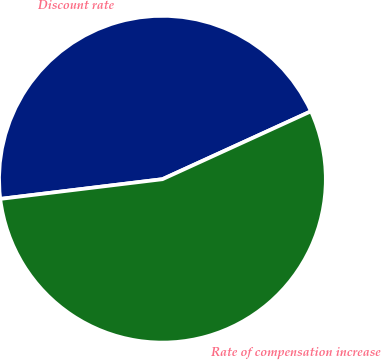<chart> <loc_0><loc_0><loc_500><loc_500><pie_chart><fcel>Discount rate<fcel>Rate of compensation increase<nl><fcel>45.1%<fcel>54.9%<nl></chart> 